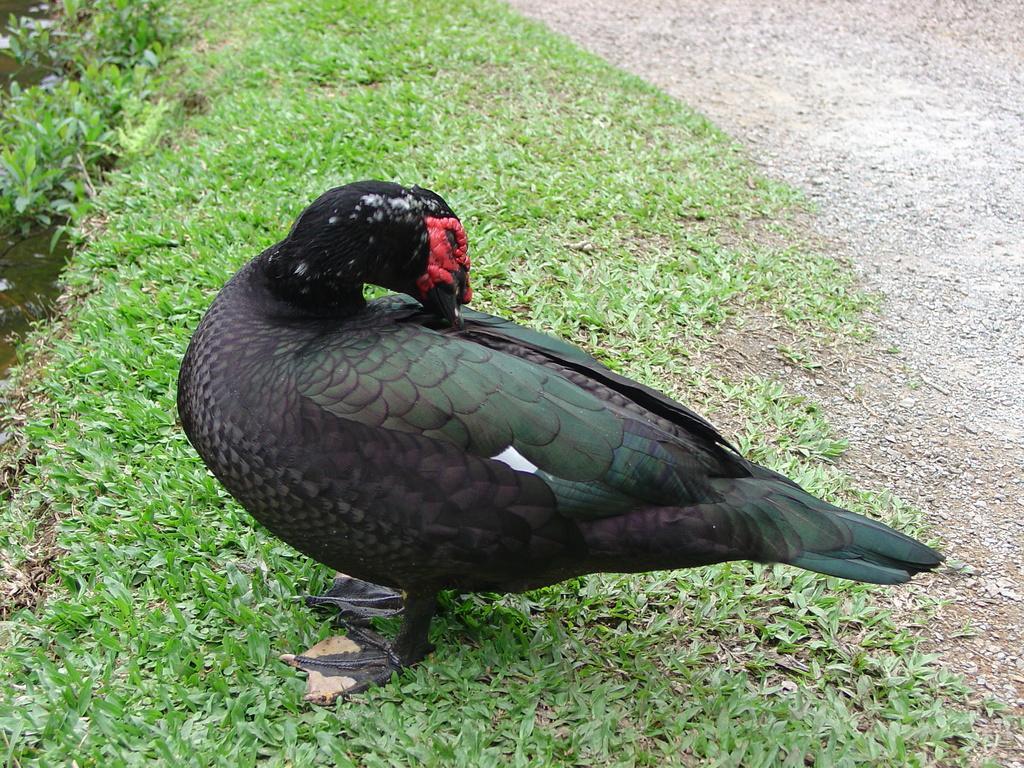In one or two sentences, can you explain what this image depicts? In this image there is a bird on the surface of the grass. In front of her there is water. 